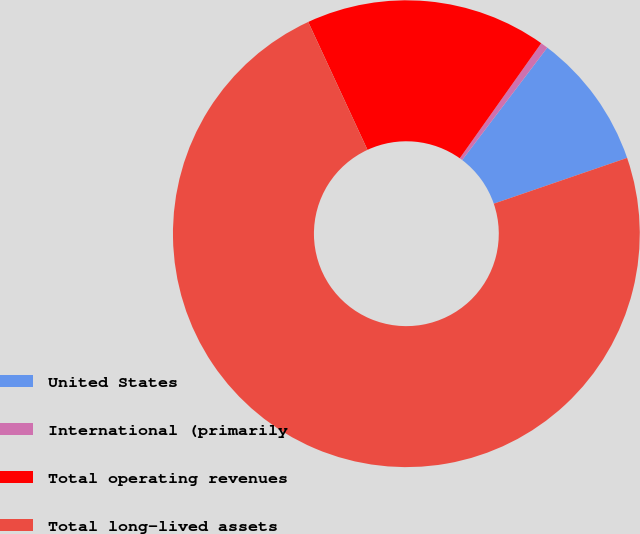Convert chart to OTSL. <chart><loc_0><loc_0><loc_500><loc_500><pie_chart><fcel>United States<fcel>International (primarily<fcel>Total operating revenues<fcel>Total long-lived assets<nl><fcel>9.42%<fcel>0.51%<fcel>16.71%<fcel>73.35%<nl></chart> 